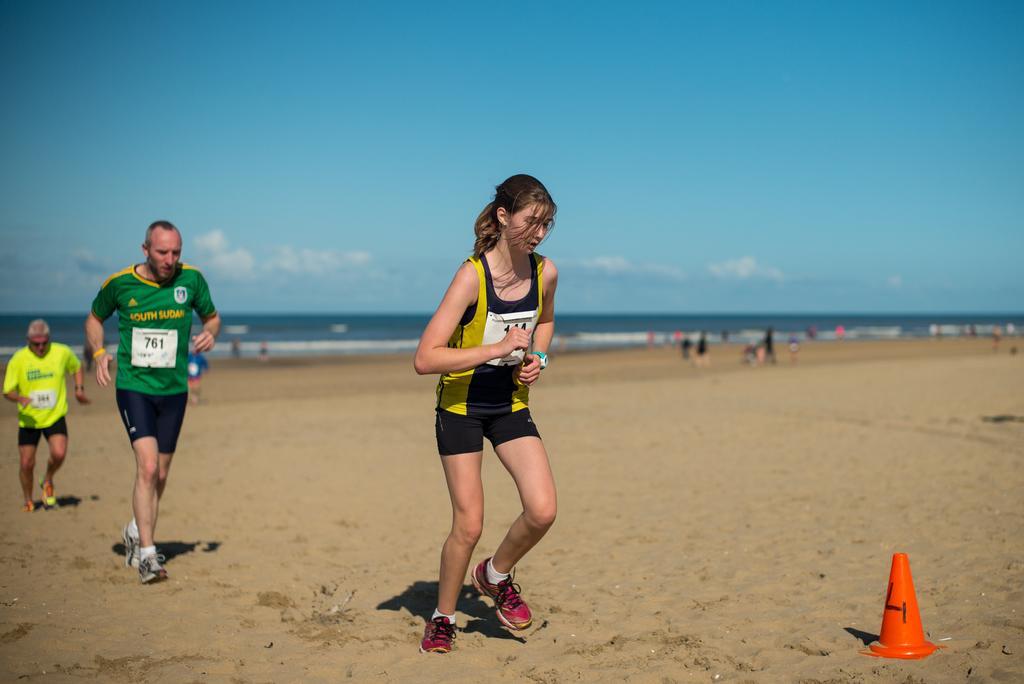Please provide a concise description of this image. In this picture we can see group of people and few are running, in the background we can find clouds and sea, in the bottom right hand corner we can see a cone. 